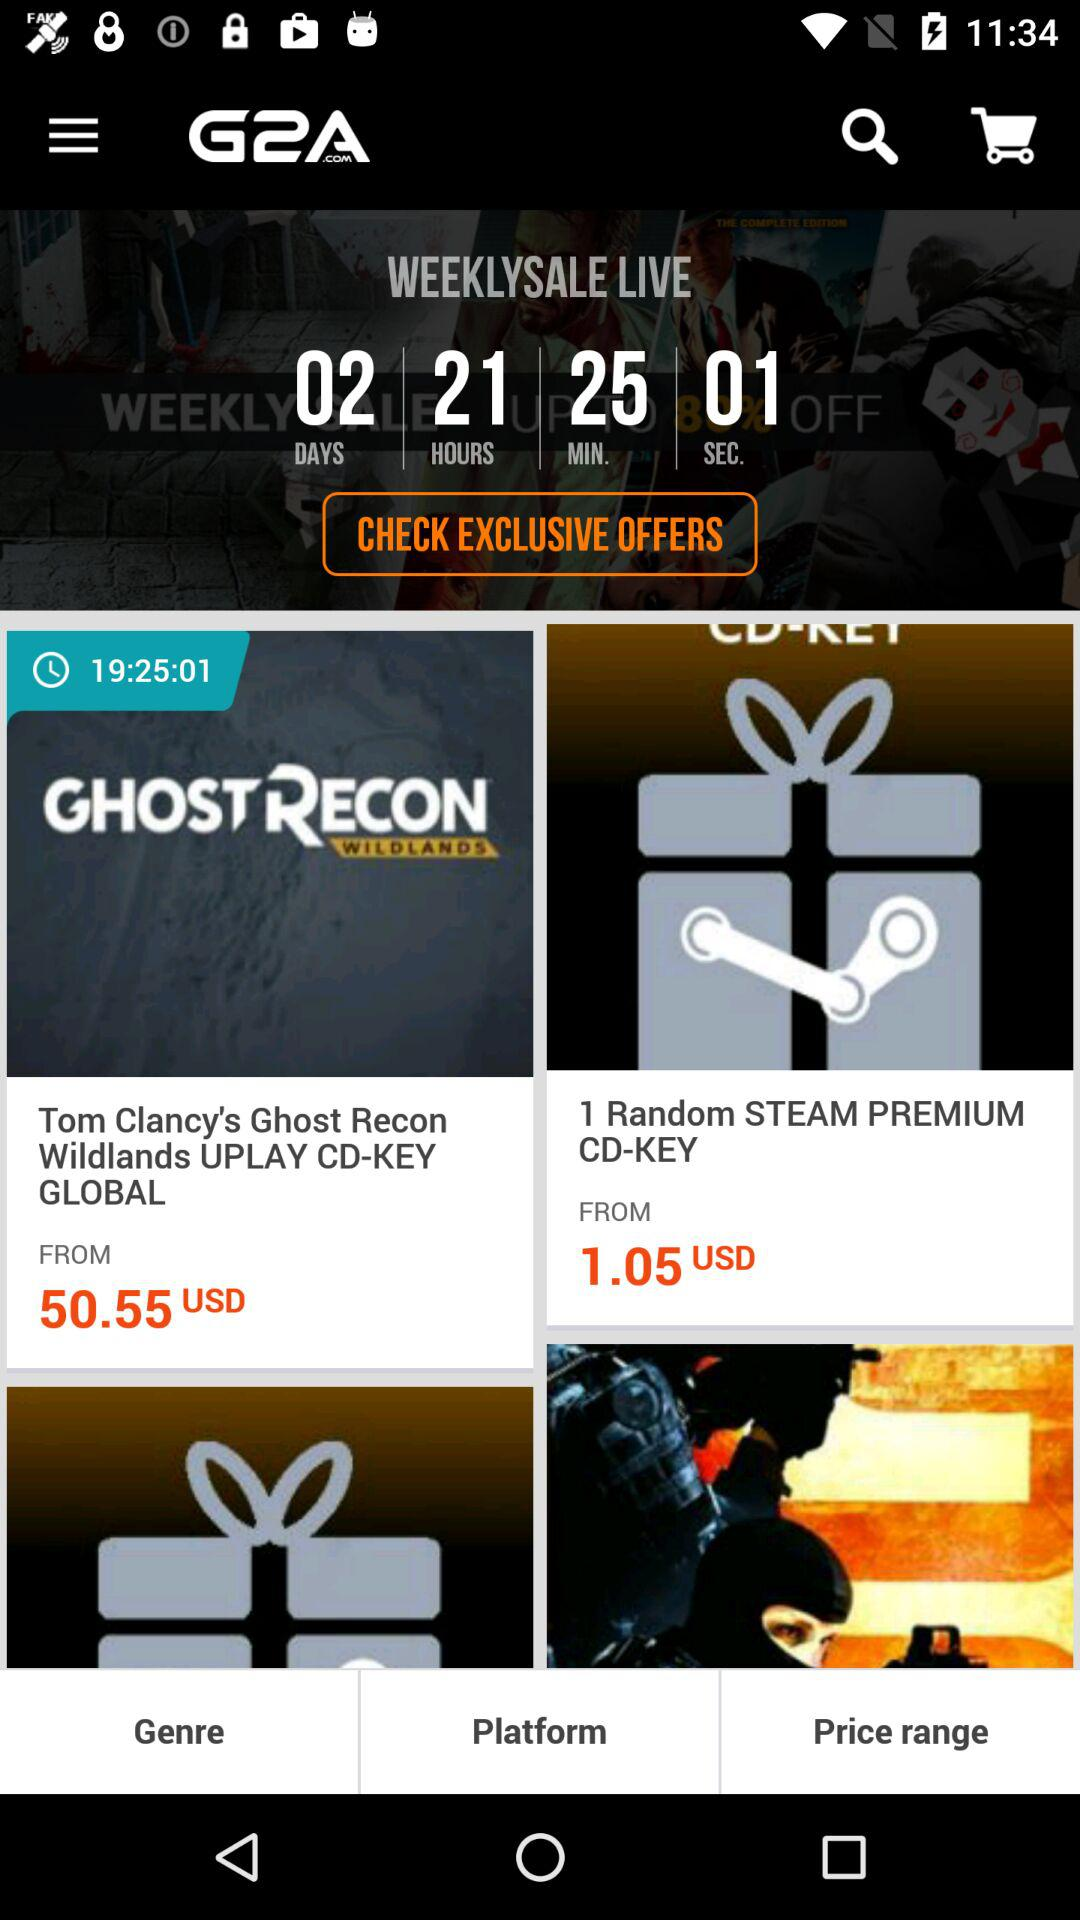What is the remaining time for the weekly sale? The remaining time for the weekly sale is 02 days, 21 hours, 25 minutes, and 01 seconds. 